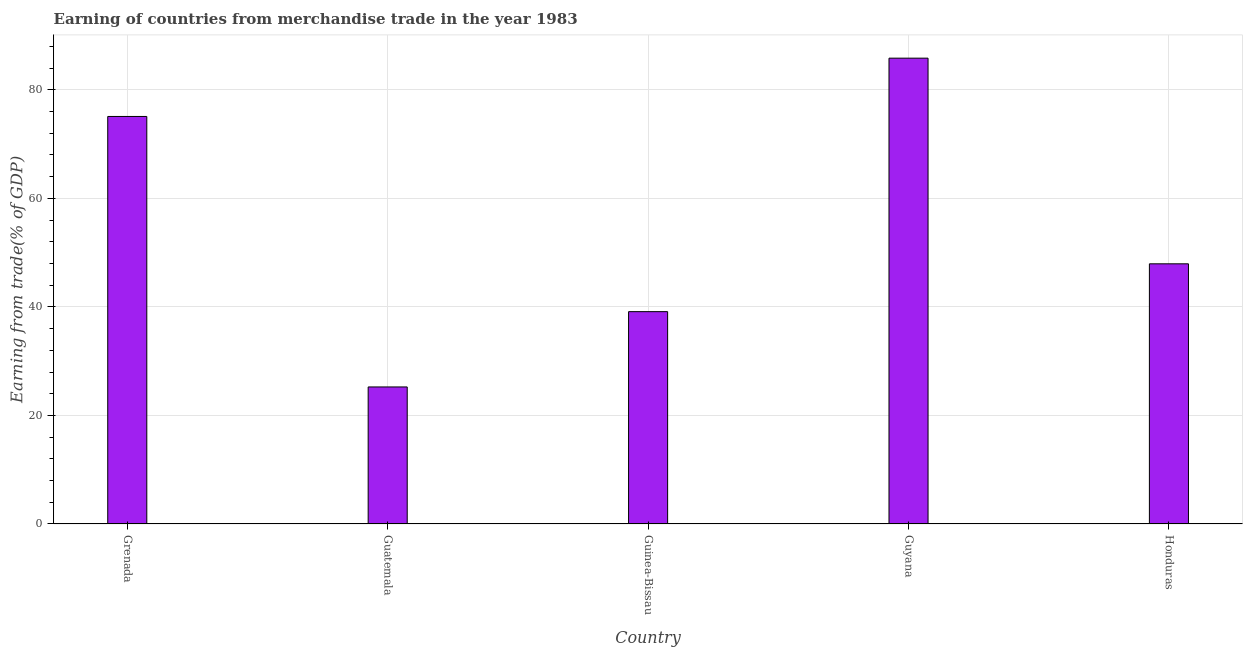What is the title of the graph?
Offer a very short reply. Earning of countries from merchandise trade in the year 1983. What is the label or title of the Y-axis?
Offer a terse response. Earning from trade(% of GDP). What is the earning from merchandise trade in Grenada?
Your answer should be compact. 75.09. Across all countries, what is the maximum earning from merchandise trade?
Your answer should be compact. 85.83. Across all countries, what is the minimum earning from merchandise trade?
Make the answer very short. 25.25. In which country was the earning from merchandise trade maximum?
Provide a short and direct response. Guyana. In which country was the earning from merchandise trade minimum?
Provide a short and direct response. Guatemala. What is the sum of the earning from merchandise trade?
Give a very brief answer. 273.23. What is the difference between the earning from merchandise trade in Guinea-Bissau and Honduras?
Provide a short and direct response. -8.81. What is the average earning from merchandise trade per country?
Your answer should be compact. 54.65. What is the median earning from merchandise trade?
Your answer should be compact. 47.94. In how many countries, is the earning from merchandise trade greater than 64 %?
Your answer should be compact. 2. What is the ratio of the earning from merchandise trade in Grenada to that in Guyana?
Offer a terse response. 0.88. Is the difference between the earning from merchandise trade in Grenada and Guyana greater than the difference between any two countries?
Give a very brief answer. No. What is the difference between the highest and the second highest earning from merchandise trade?
Your answer should be compact. 10.74. What is the difference between the highest and the lowest earning from merchandise trade?
Your response must be concise. 60.58. How many bars are there?
Offer a terse response. 5. Are all the bars in the graph horizontal?
Ensure brevity in your answer.  No. How many countries are there in the graph?
Your answer should be very brief. 5. What is the Earning from trade(% of GDP) of Grenada?
Your answer should be compact. 75.09. What is the Earning from trade(% of GDP) of Guatemala?
Keep it short and to the point. 25.25. What is the Earning from trade(% of GDP) in Guinea-Bissau?
Make the answer very short. 39.13. What is the Earning from trade(% of GDP) of Guyana?
Ensure brevity in your answer.  85.83. What is the Earning from trade(% of GDP) in Honduras?
Ensure brevity in your answer.  47.94. What is the difference between the Earning from trade(% of GDP) in Grenada and Guatemala?
Give a very brief answer. 49.84. What is the difference between the Earning from trade(% of GDP) in Grenada and Guinea-Bissau?
Offer a very short reply. 35.97. What is the difference between the Earning from trade(% of GDP) in Grenada and Guyana?
Provide a short and direct response. -10.74. What is the difference between the Earning from trade(% of GDP) in Grenada and Honduras?
Your answer should be very brief. 27.15. What is the difference between the Earning from trade(% of GDP) in Guatemala and Guinea-Bissau?
Your answer should be compact. -13.88. What is the difference between the Earning from trade(% of GDP) in Guatemala and Guyana?
Make the answer very short. -60.58. What is the difference between the Earning from trade(% of GDP) in Guatemala and Honduras?
Keep it short and to the point. -22.69. What is the difference between the Earning from trade(% of GDP) in Guinea-Bissau and Guyana?
Your answer should be very brief. -46.71. What is the difference between the Earning from trade(% of GDP) in Guinea-Bissau and Honduras?
Your response must be concise. -8.81. What is the difference between the Earning from trade(% of GDP) in Guyana and Honduras?
Keep it short and to the point. 37.89. What is the ratio of the Earning from trade(% of GDP) in Grenada to that in Guatemala?
Provide a succinct answer. 2.97. What is the ratio of the Earning from trade(% of GDP) in Grenada to that in Guinea-Bissau?
Give a very brief answer. 1.92. What is the ratio of the Earning from trade(% of GDP) in Grenada to that in Honduras?
Offer a very short reply. 1.57. What is the ratio of the Earning from trade(% of GDP) in Guatemala to that in Guinea-Bissau?
Ensure brevity in your answer.  0.65. What is the ratio of the Earning from trade(% of GDP) in Guatemala to that in Guyana?
Offer a very short reply. 0.29. What is the ratio of the Earning from trade(% of GDP) in Guatemala to that in Honduras?
Offer a very short reply. 0.53. What is the ratio of the Earning from trade(% of GDP) in Guinea-Bissau to that in Guyana?
Your response must be concise. 0.46. What is the ratio of the Earning from trade(% of GDP) in Guinea-Bissau to that in Honduras?
Provide a succinct answer. 0.82. What is the ratio of the Earning from trade(% of GDP) in Guyana to that in Honduras?
Offer a very short reply. 1.79. 